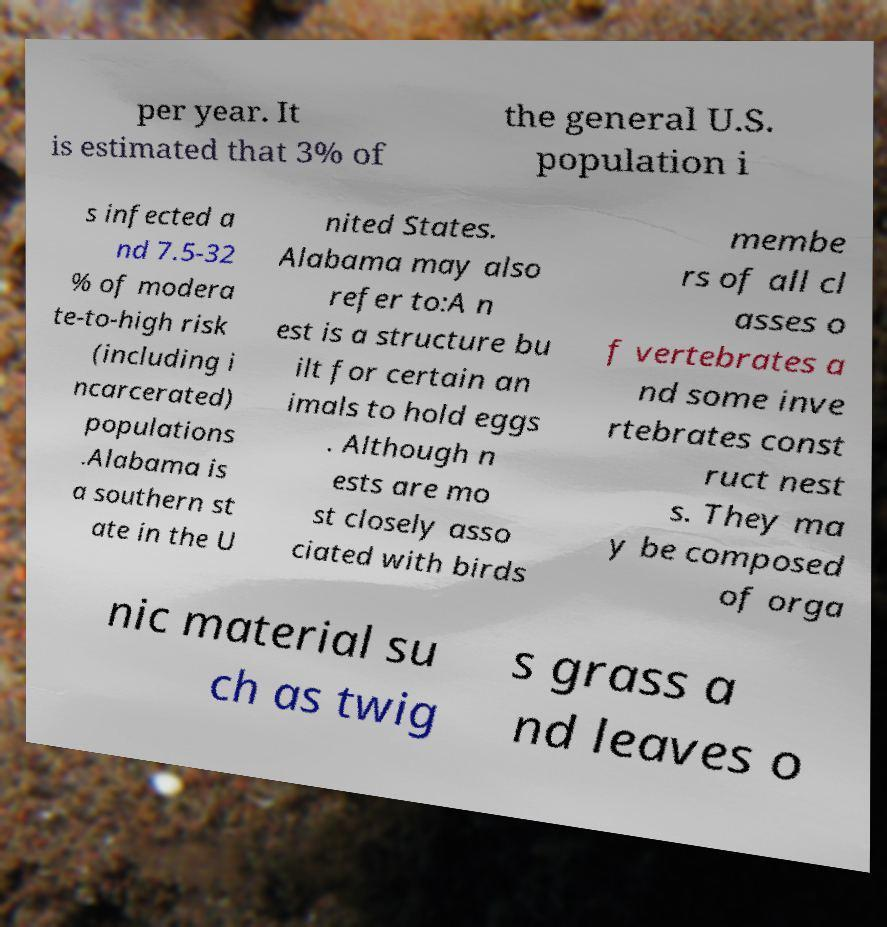Can you read and provide the text displayed in the image?This photo seems to have some interesting text. Can you extract and type it out for me? per year. It is estimated that 3% of the general U.S. population i s infected a nd 7.5-32 % of modera te-to-high risk (including i ncarcerated) populations .Alabama is a southern st ate in the U nited States. Alabama may also refer to:A n est is a structure bu ilt for certain an imals to hold eggs . Although n ests are mo st closely asso ciated with birds membe rs of all cl asses o f vertebrates a nd some inve rtebrates const ruct nest s. They ma y be composed of orga nic material su ch as twig s grass a nd leaves o 